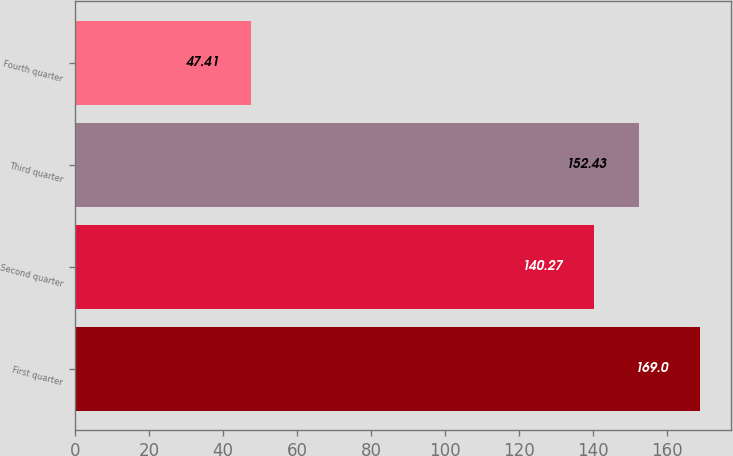Convert chart. <chart><loc_0><loc_0><loc_500><loc_500><bar_chart><fcel>First quarter<fcel>Second quarter<fcel>Third quarter<fcel>Fourth quarter<nl><fcel>169<fcel>140.27<fcel>152.43<fcel>47.41<nl></chart> 